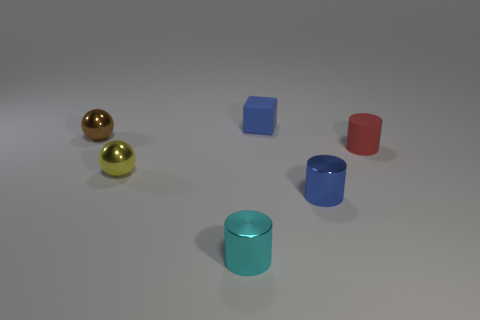Subtract all red matte cylinders. How many cylinders are left? 2 Add 2 spheres. How many objects exist? 8 Subtract all blocks. How many objects are left? 5 Subtract all gray cylinders. Subtract all blue blocks. How many cylinders are left? 3 Add 6 tiny yellow objects. How many tiny yellow objects exist? 7 Subtract 0 brown cubes. How many objects are left? 6 Subtract all tiny blue things. Subtract all large purple matte blocks. How many objects are left? 4 Add 2 small metallic things. How many small metallic things are left? 6 